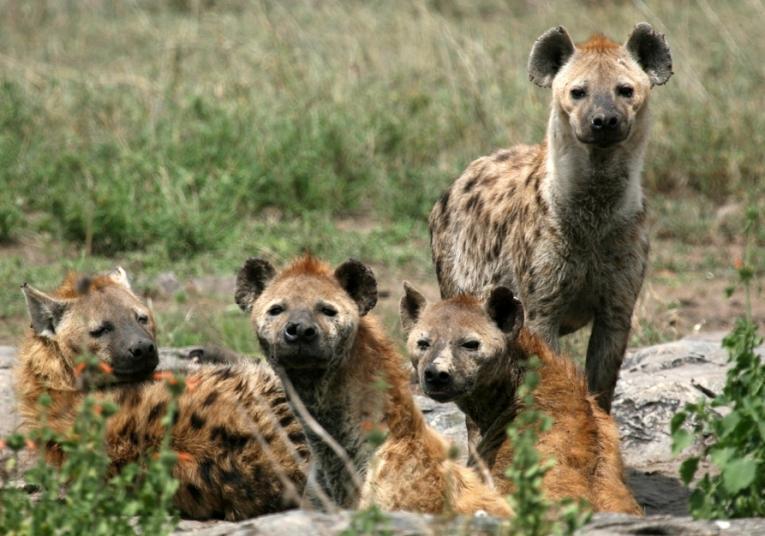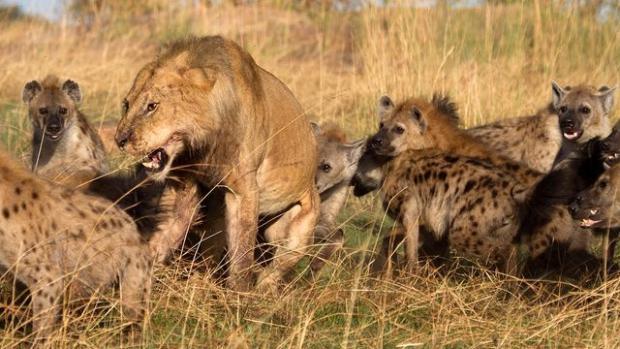The first image is the image on the left, the second image is the image on the right. For the images shown, is this caption "An open-mouthed lion is near a hyena in one image." true? Answer yes or no. Yes. 